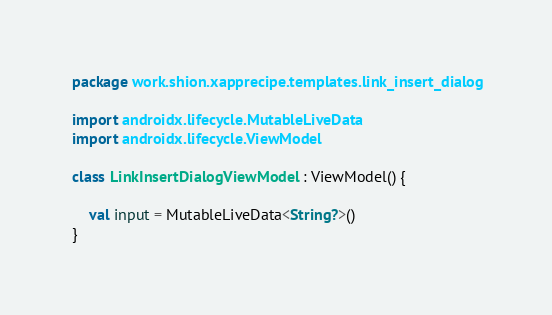<code> <loc_0><loc_0><loc_500><loc_500><_Kotlin_>package work.shion.xapprecipe.templates.link_insert_dialog

import androidx.lifecycle.MutableLiveData
import androidx.lifecycle.ViewModel

class LinkInsertDialogViewModel : ViewModel() {

    val input = MutableLiveData<String?>()
}
</code> 